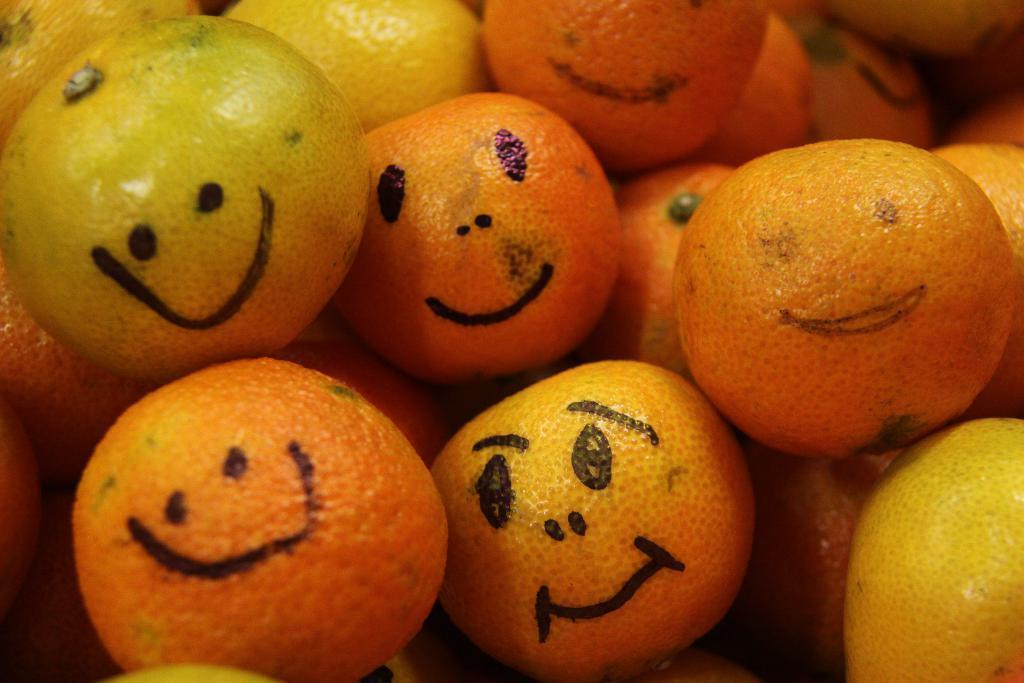Can you describe this image briefly? In this picture we can see some oranges, we can see drawings of smiley symbols on these oranges. 